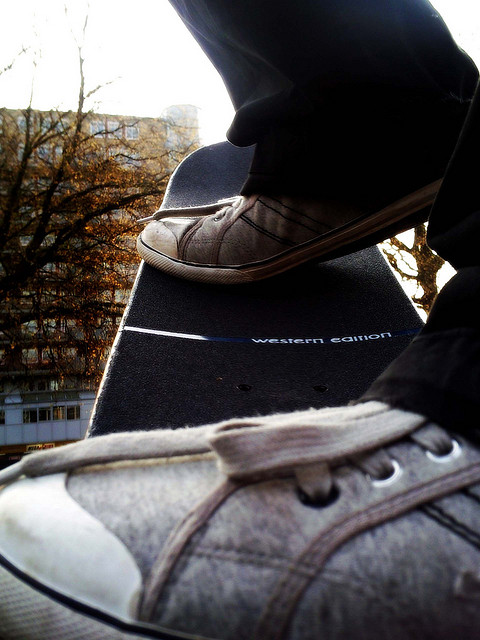Read all the text in this image. Western cainon 